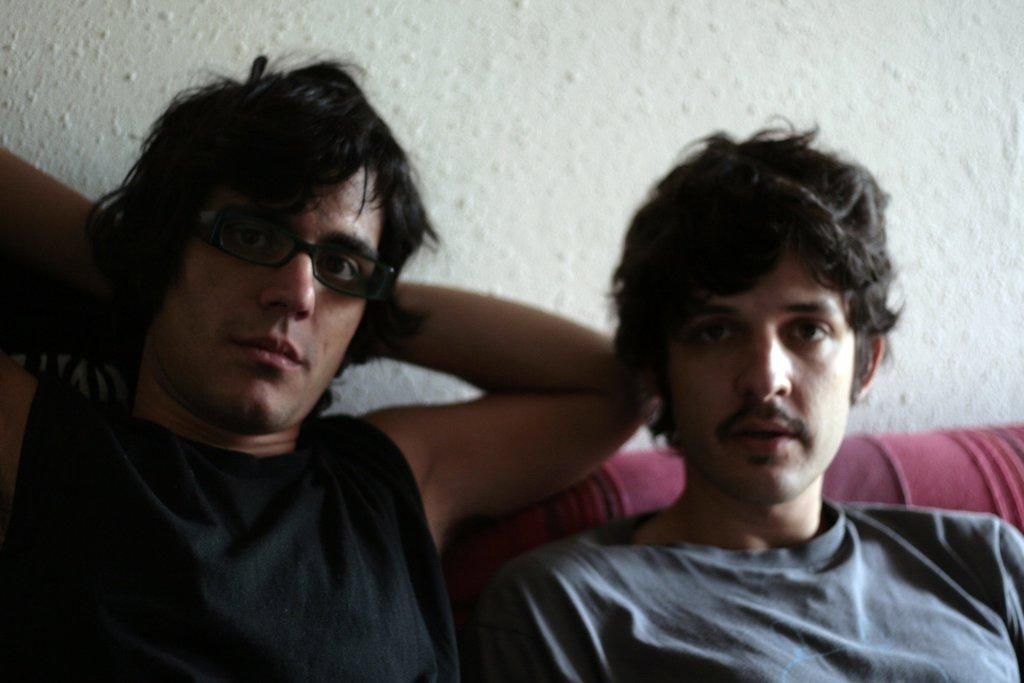How many people are in the image? There are two men in the image. What are the men doing in the image? The men are sitting on a sofa. Can you describe the appearance of the man on the left side? The man on the left side is wearing spectacles. What can be seen in the background of the image? There is a white wall in the background of the image. What might be the reason for the men's positioning in the image? The men might be posing for the photo. What type of addition can be seen hanging from the ceiling in the image? There is no addition hanging from the ceiling in the image. Can you describe the icicle formation on the sofa in the image? There are no icicles present in the image; it is an indoor setting with a sofa and two men. 